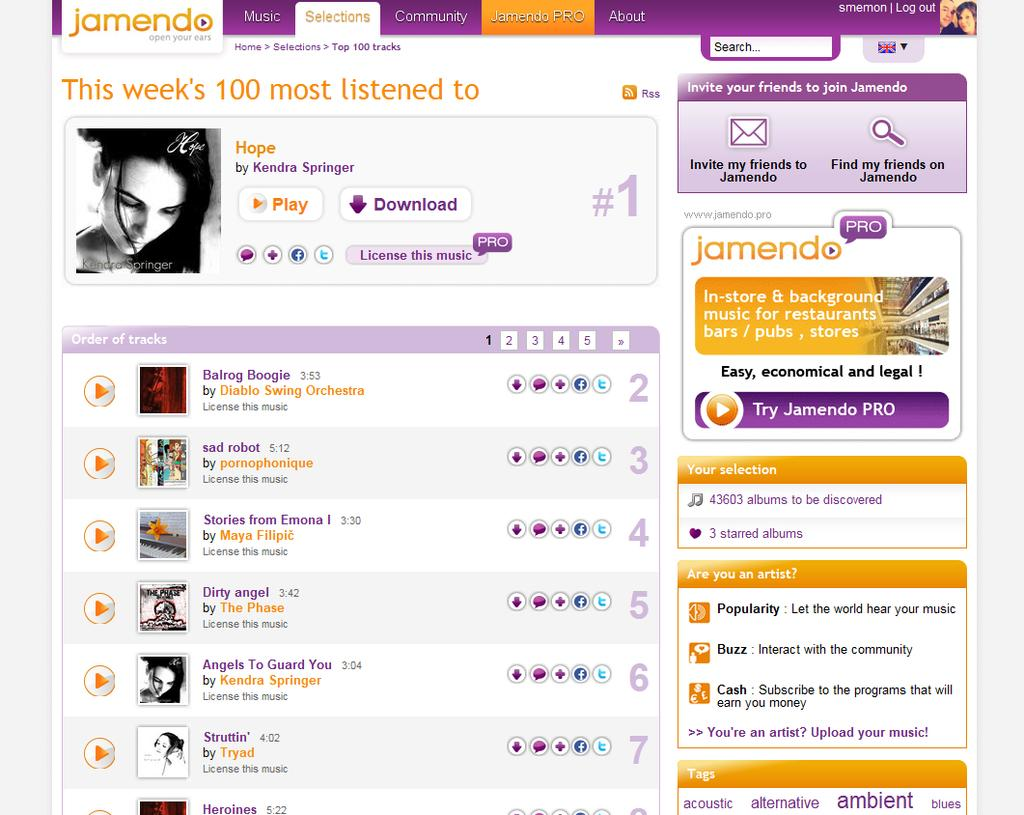What can be seen in the image that is related to visual representation? There are pictures in the image. What type of text is present in the image? There are words and numbers written in the image. What symbol can be seen in the image? There is a flag in the image. What type of crime is being committed in the image? There is no indication of a crime being committed in the image. How does the flag relate to the stomach in the image? There is no stomach present in the image, and the flag is not associated with any stomach-related elements. 